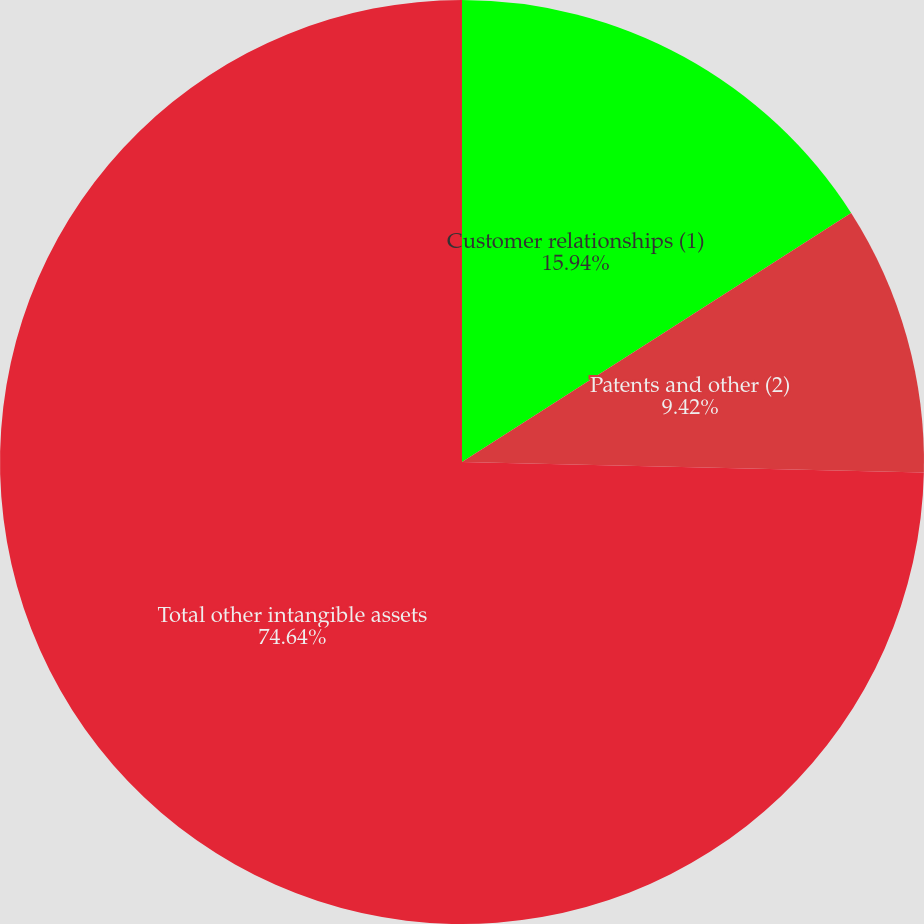<chart> <loc_0><loc_0><loc_500><loc_500><pie_chart><fcel>Customer relationships (1)<fcel>Patents and other (2)<fcel>Total other intangible assets<nl><fcel>15.94%<fcel>9.42%<fcel>74.64%<nl></chart> 